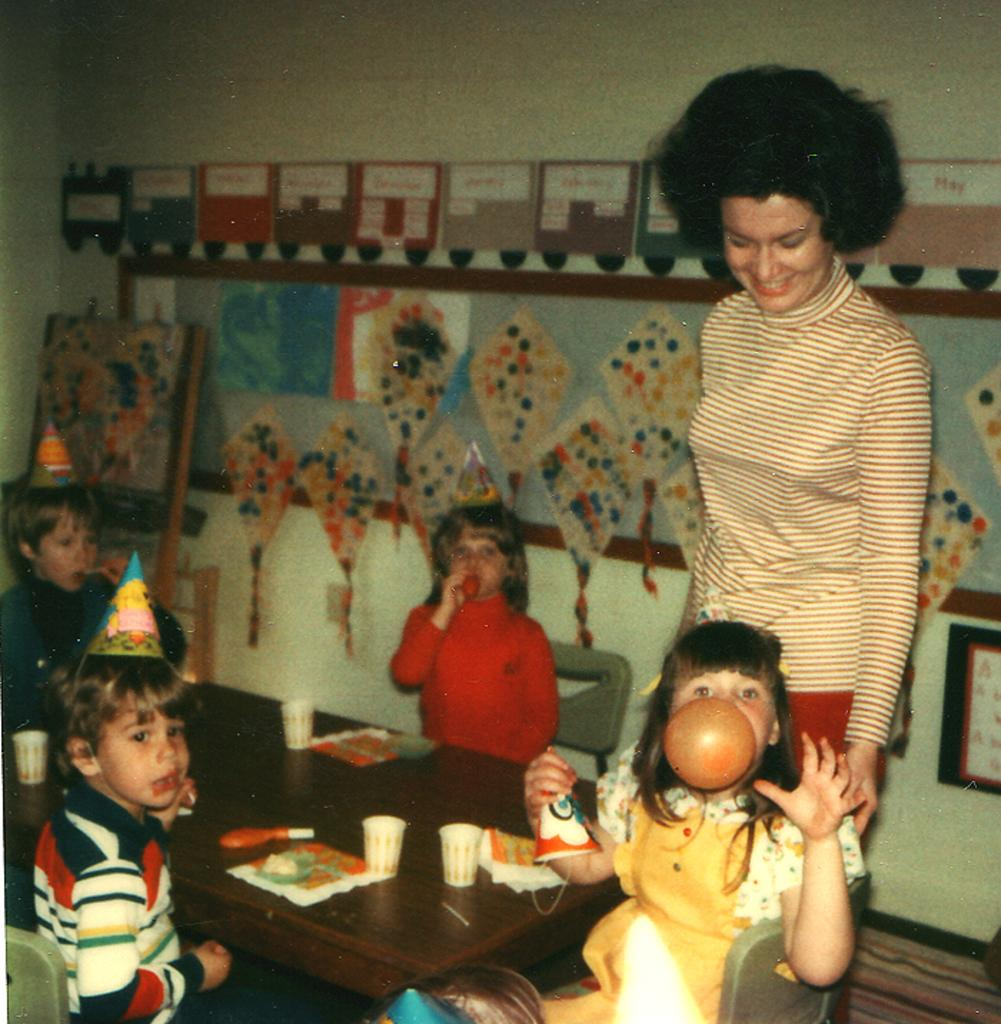Who is present in the image? There is a person in the image. Who else can be seen in the image? There are kids in the image. What is in the image that might be used for eating or working? There is a table in the image. What is placed on the table? There are things placed on the table. What is against the wall in the image? There are objects against the wall in the image. What type of calculator is being used by the person in the image? There is no calculator present in the image. What is the person using to clean the floor in the image? There is no cloth or indication of cleaning the floor in the image. 